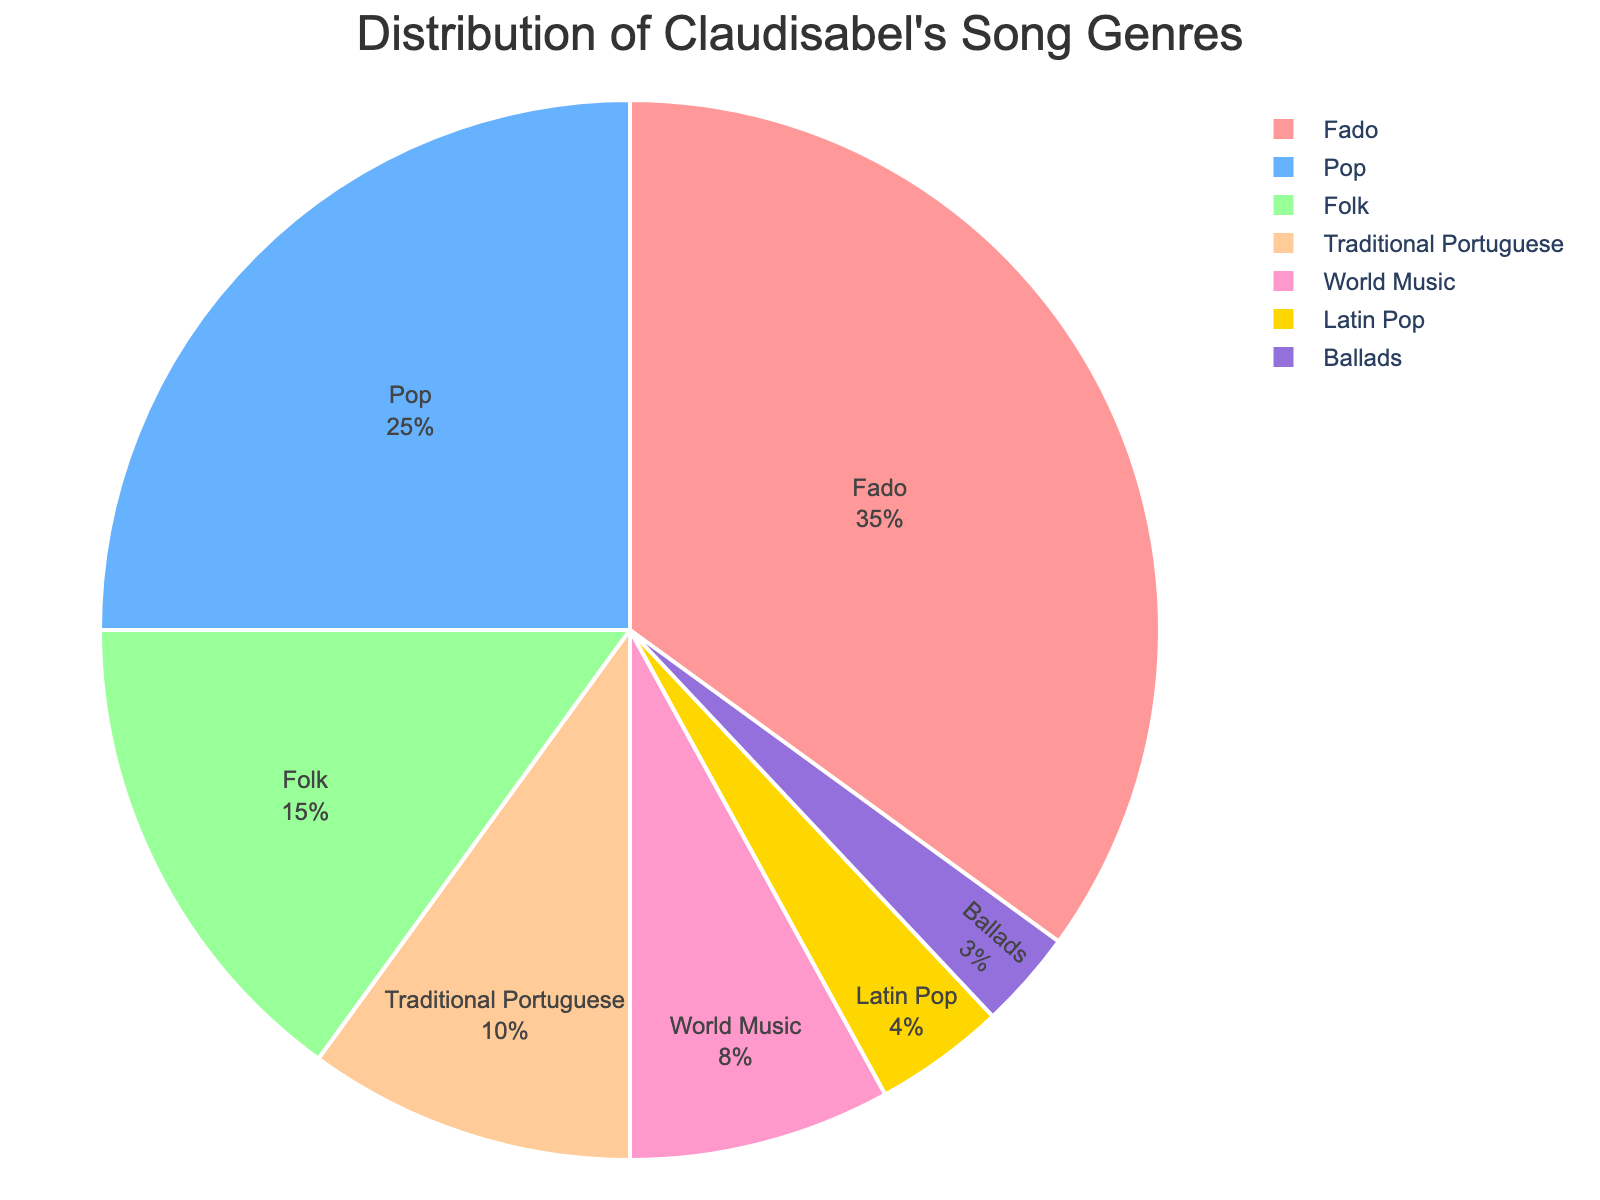What percentage of Claudisabel's songs are in the Fado genre? Look at the pie chart segment labeled "Fado" and read the percentage value associated with it.
Answer: 35% Which genre has the smallest distribution and what is its percentage? Identify the smallest slice in the pie chart. The smallest slice corresponds to "Ballads," and note the percentage provided.
Answer: Ballads, 3% How much more prevalent are Fado songs compared to Latin Pop? Find the percentages for Fado and Latin Pop. Subtract the percentage of Latin Pop from the percentage of Fado.
Answer: 35% - 4% = 31% What two genres combined equate to the same percentage as Pop songs? Look for two genres whose summed percentages equal the percentage of Pop songs. "Folk" and "Traditional Portuguese" combined equal 15% + 10%, which is the same as Pop's 25%.
Answer: Folk and Traditional Portuguese What fraction of Claudisabel's songs are categorized as either Pop or Fado? Add the percentages of Pop and Fado. Then convert the sum percentage into a fraction out of 100.
Answer: (35% + 25%) = 60%, fraction is 60/100 Which genre, World Music or Traditional Portuguese, has a higher percentage and by how much? Compare the percentages of World Music and Traditional Portuguese. Subtract the smaller percentage (Traditional Portuguese) from the larger one (World Music).
Answer: Traditional Portuguese, 10% - 8% = 2% If Claudisabel's total number of songs is 100, how many songs belong to the Folk genre? Use the percentage of Folk songs to calculate the number of songs. Multiply the total number of songs (100) by the percentage of Folk (0.15).
Answer: 0.15 * 100 = 15 What is the color of the pie chart segment representing Latin Pop? Look at the pie chart and identify the color assigned to the "Latin Pop" segment.
Answer: Gold Calculate the aggregate percentage of genres that have more than 10% distribution. Identify all genres with more than 10% distribution (Fado, Pop, and Folk). Sum their percentages.
Answer: 35% + 25% + 15% = 75% Compare the total percentage of Ballads and World Music with that of Traditional Portuguese. Which one is larger and by how much? Sum the percentages of Ballads and World Music. Compare with the percentage of Traditional Portuguese and subtract the smaller from the larger.
Answer: World Music + Ballads = 8% + 3% = 11%, Traditional Portuguese is 10%, so 11% - 10% = 1% 